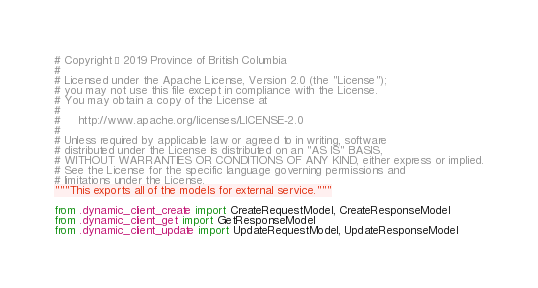Convert code to text. <code><loc_0><loc_0><loc_500><loc_500><_Python_># Copyright © 2019 Province of British Columbia
#
# Licensed under the Apache License, Version 2.0 (the "License");
# you may not use this file except in compliance with the License.
# You may obtain a copy of the License at
#
#     http://www.apache.org/licenses/LICENSE-2.0
#
# Unless required by applicable law or agreed to in writing, software
# distributed under the License is distributed on an "AS IS" BASIS,
# WITHOUT WARRANTIES OR CONDITIONS OF ANY KIND, either express or implied.
# See the License for the specific language governing permissions and
# limitations under the License.
"""This exports all of the models for external service."""

from .dynamic_client_create import CreateRequestModel, CreateResponseModel
from .dynamic_client_get import GetResponseModel
from .dynamic_client_update import UpdateRequestModel, UpdateResponseModel
</code> 